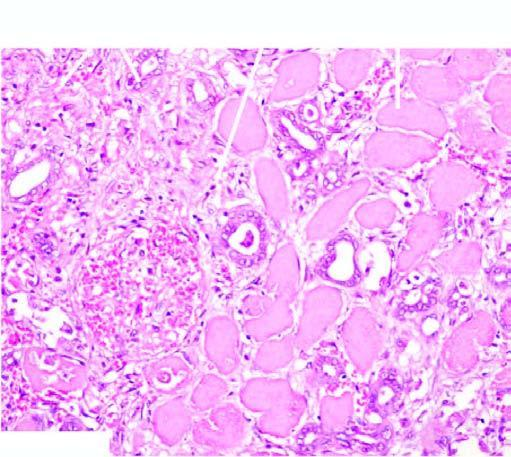where is acute inflammatory infiltrate at?
Answer the question using a single word or phrase. The periphery of the infarct 